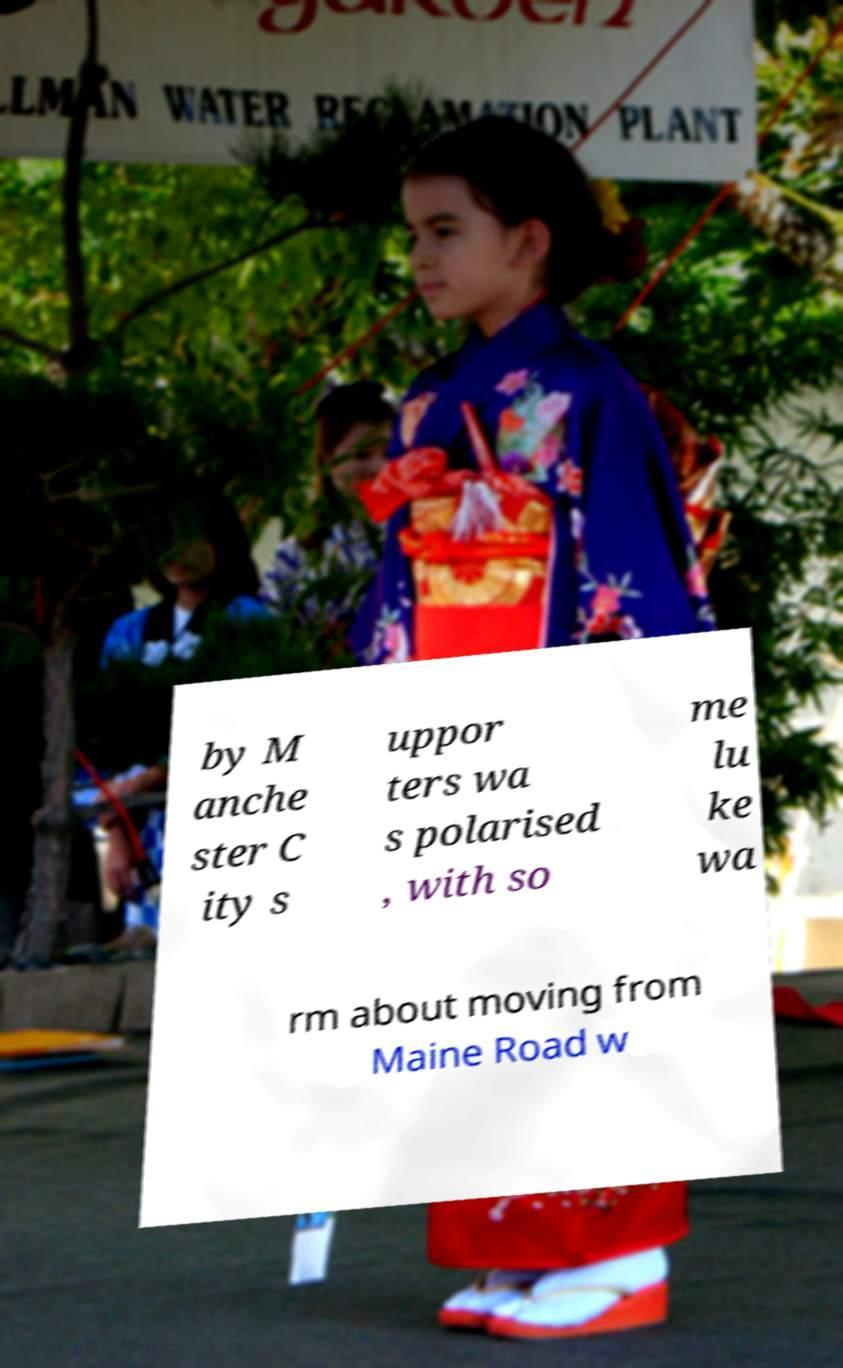For documentation purposes, I need the text within this image transcribed. Could you provide that? by M anche ster C ity s uppor ters wa s polarised , with so me lu ke wa rm about moving from Maine Road w 